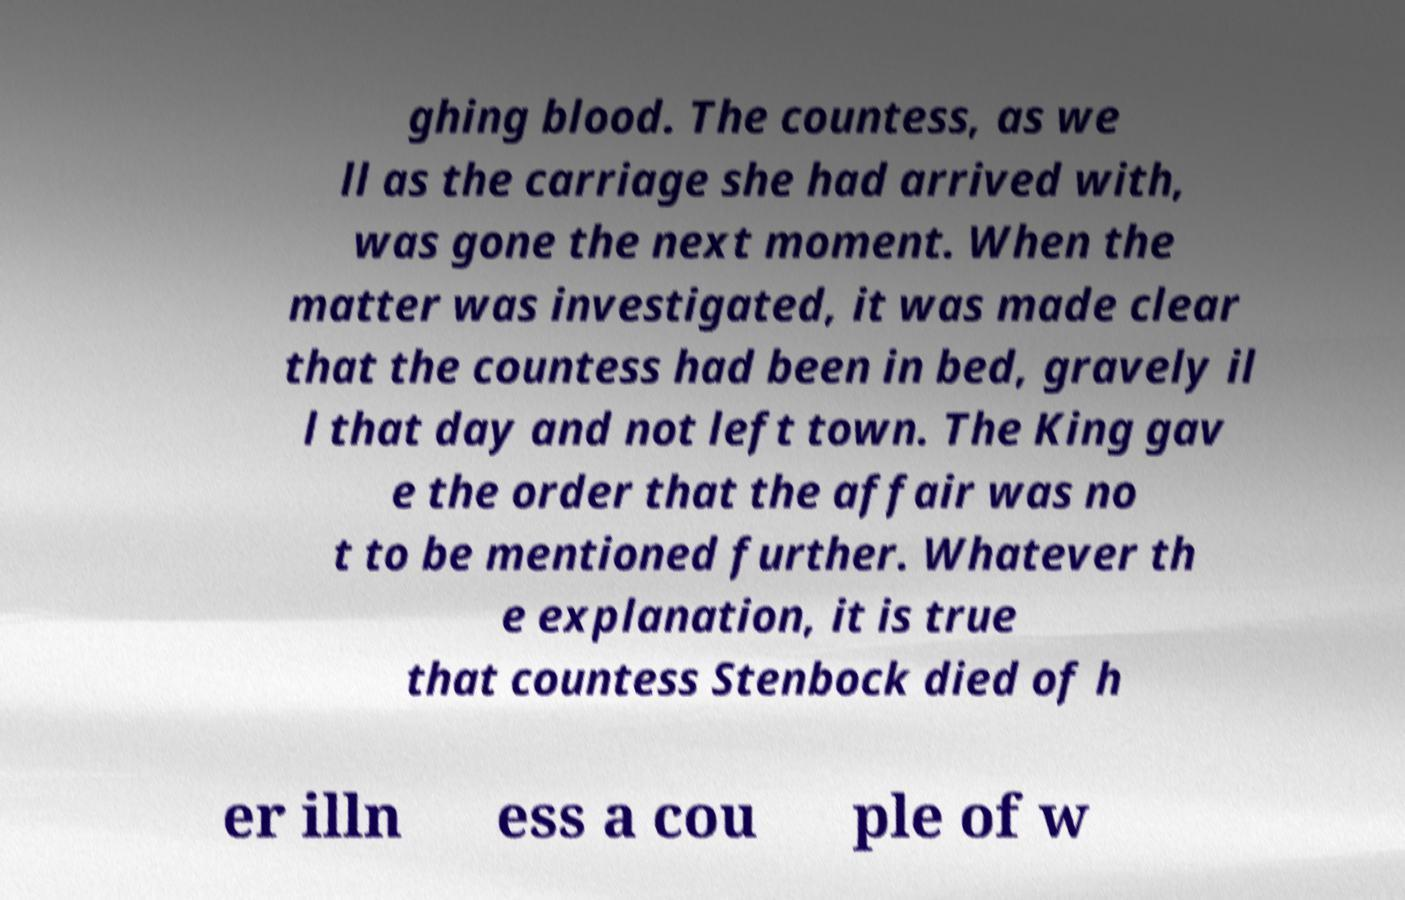What messages or text are displayed in this image? I need them in a readable, typed format. ghing blood. The countess, as we ll as the carriage she had arrived with, was gone the next moment. When the matter was investigated, it was made clear that the countess had been in bed, gravely il l that day and not left town. The King gav e the order that the affair was no t to be mentioned further. Whatever th e explanation, it is true that countess Stenbock died of h er illn ess a cou ple of w 